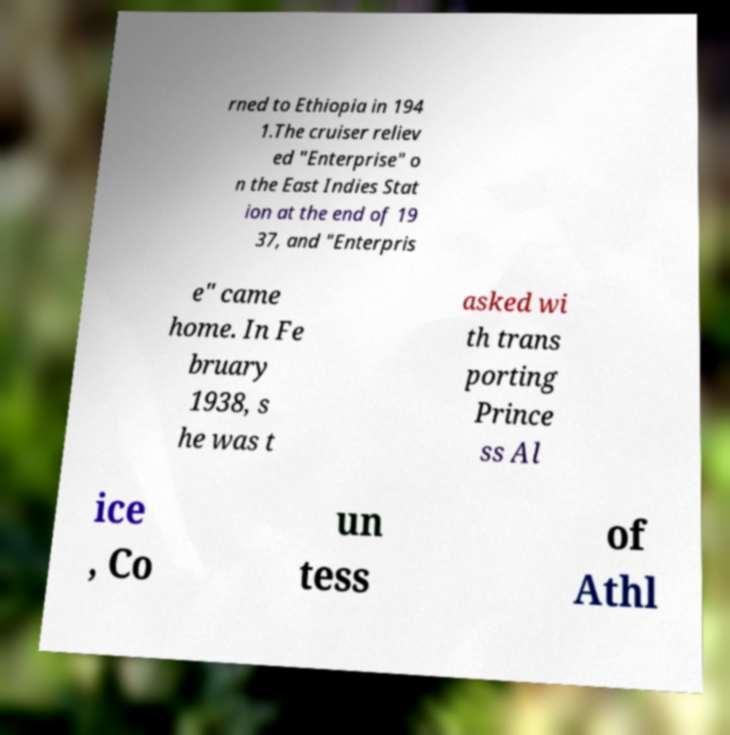Please read and relay the text visible in this image. What does it say? rned to Ethiopia in 194 1.The cruiser reliev ed "Enterprise" o n the East Indies Stat ion at the end of 19 37, and "Enterpris e" came home. In Fe bruary 1938, s he was t asked wi th trans porting Prince ss Al ice , Co un tess of Athl 